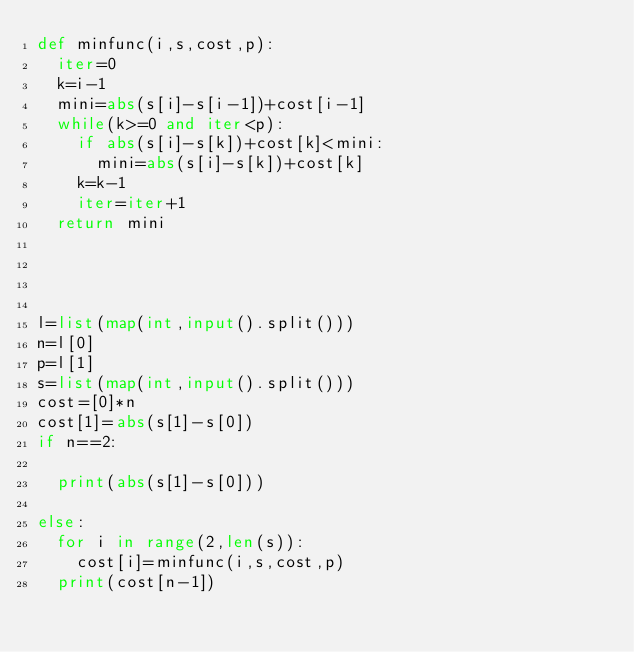Convert code to text. <code><loc_0><loc_0><loc_500><loc_500><_Python_>def minfunc(i,s,cost,p):
  iter=0
  k=i-1
  mini=abs(s[i]-s[i-1])+cost[i-1]
  while(k>=0 and iter<p):
    if abs(s[i]-s[k])+cost[k]<mini:
      mini=abs(s[i]-s[k])+cost[k]
    k=k-1
    iter=iter+1
  return mini
    
    


l=list(map(int,input().split()))
n=l[0]
p=l[1]
s=list(map(int,input().split()))
cost=[0]*n
cost[1]=abs(s[1]-s[0])
if n==2:
  
  print(abs(s[1]-s[0]))
  
else:
  for i in range(2,len(s)):
  	cost[i]=minfunc(i,s,cost,p)
  print(cost[n-1])
</code> 